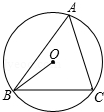Tell me what you observe in the image. The diagram depicts a circle labeled as circle O, which has the center point O. Two intersecting lines on the circumference of the circle form an angle labeled as A. From the center point O, a line is drawn to a point labeled as B. The angle formed between this line and the line connecting points O and C is labeled as OBC. 